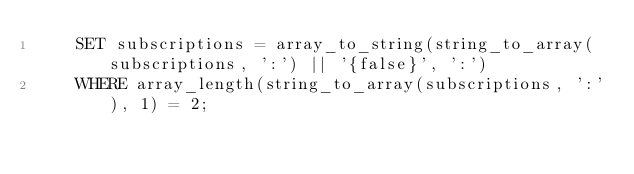Convert code to text. <code><loc_0><loc_0><loc_500><loc_500><_SQL_>    SET subscriptions = array_to_string(string_to_array(subscriptions, ':') || '{false}', ':')
    WHERE array_length(string_to_array(subscriptions, ':'), 1) = 2;</code> 